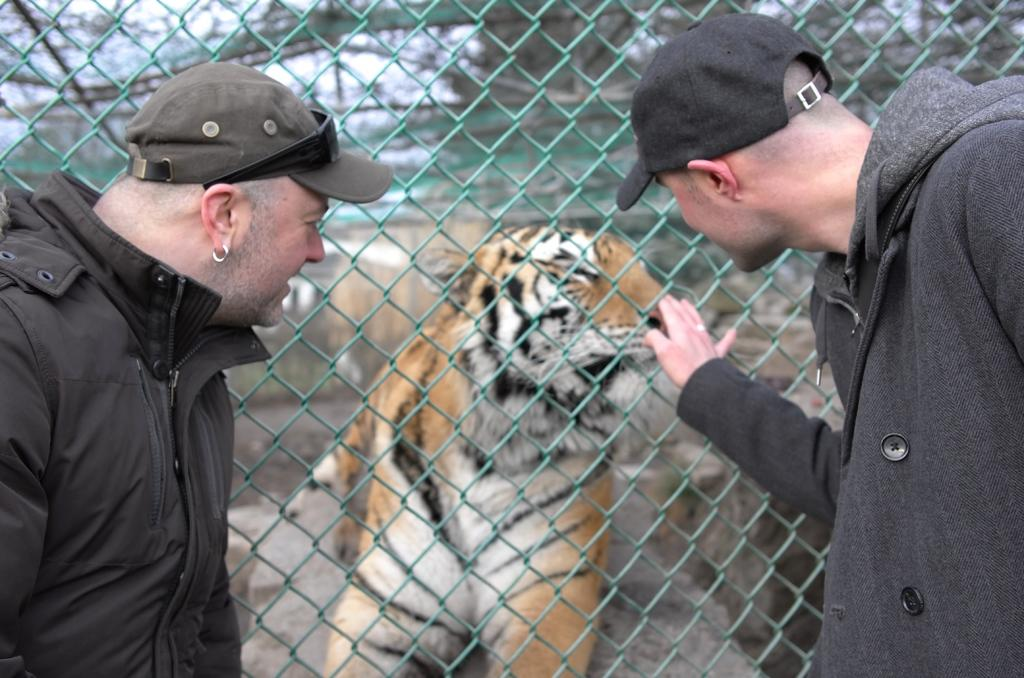How many people are in the image? There are two persons in the image. What are the persons wearing on their heads? Both persons are wearing caps. What can be seen in the background of the image? There is a fence in the background of the image. What type of animal is behind the fence in the image? There is a tiger behind the fence in the image. Can you tell me how many fans are visible in the image? There are no fans present in the image. Is there a stream running through the image? There is no stream visible in the image. 